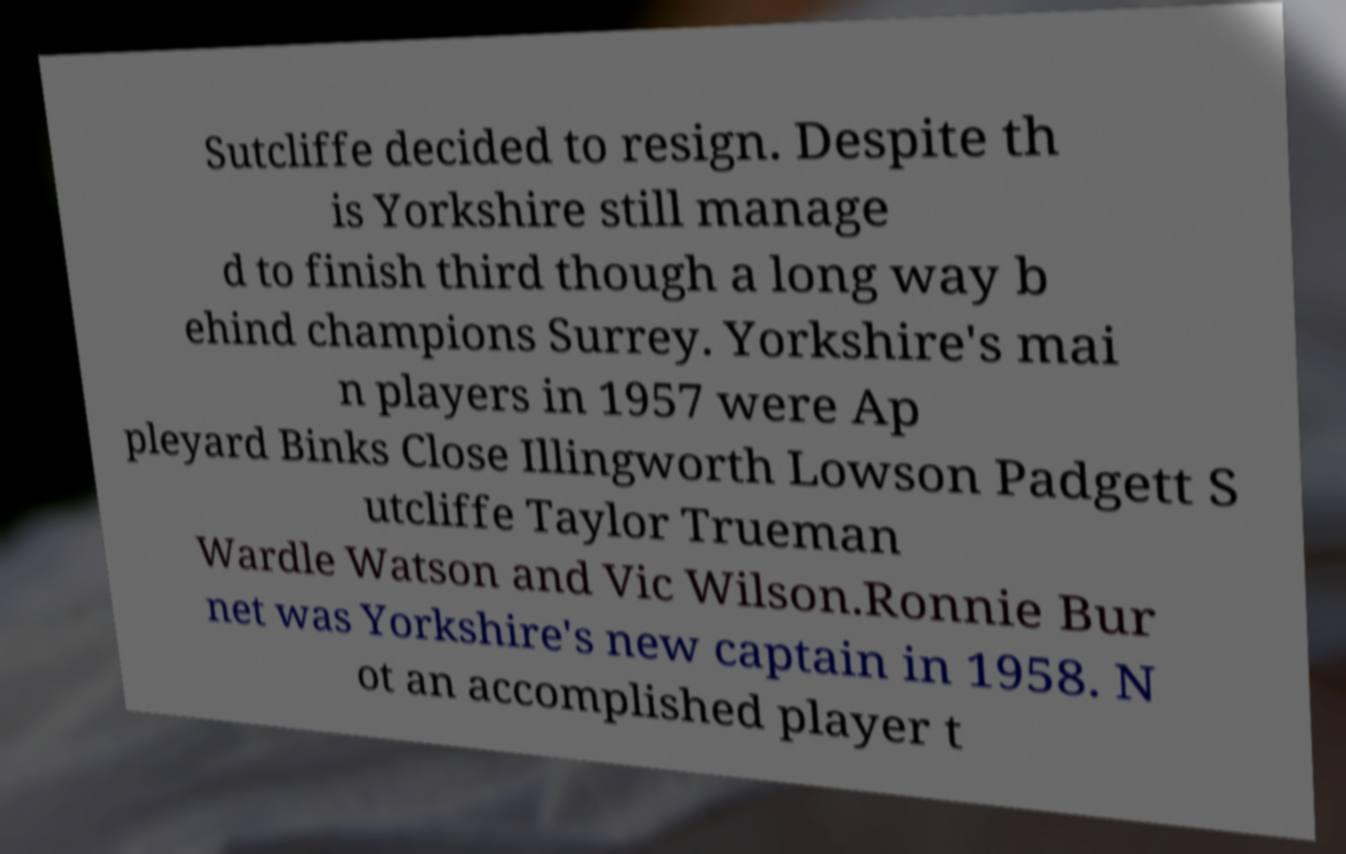Please identify and transcribe the text found in this image. Sutcliffe decided to resign. Despite th is Yorkshire still manage d to finish third though a long way b ehind champions Surrey. Yorkshire's mai n players in 1957 were Ap pleyard Binks Close Illingworth Lowson Padgett S utcliffe Taylor Trueman Wardle Watson and Vic Wilson.Ronnie Bur net was Yorkshire's new captain in 1958. N ot an accomplished player t 